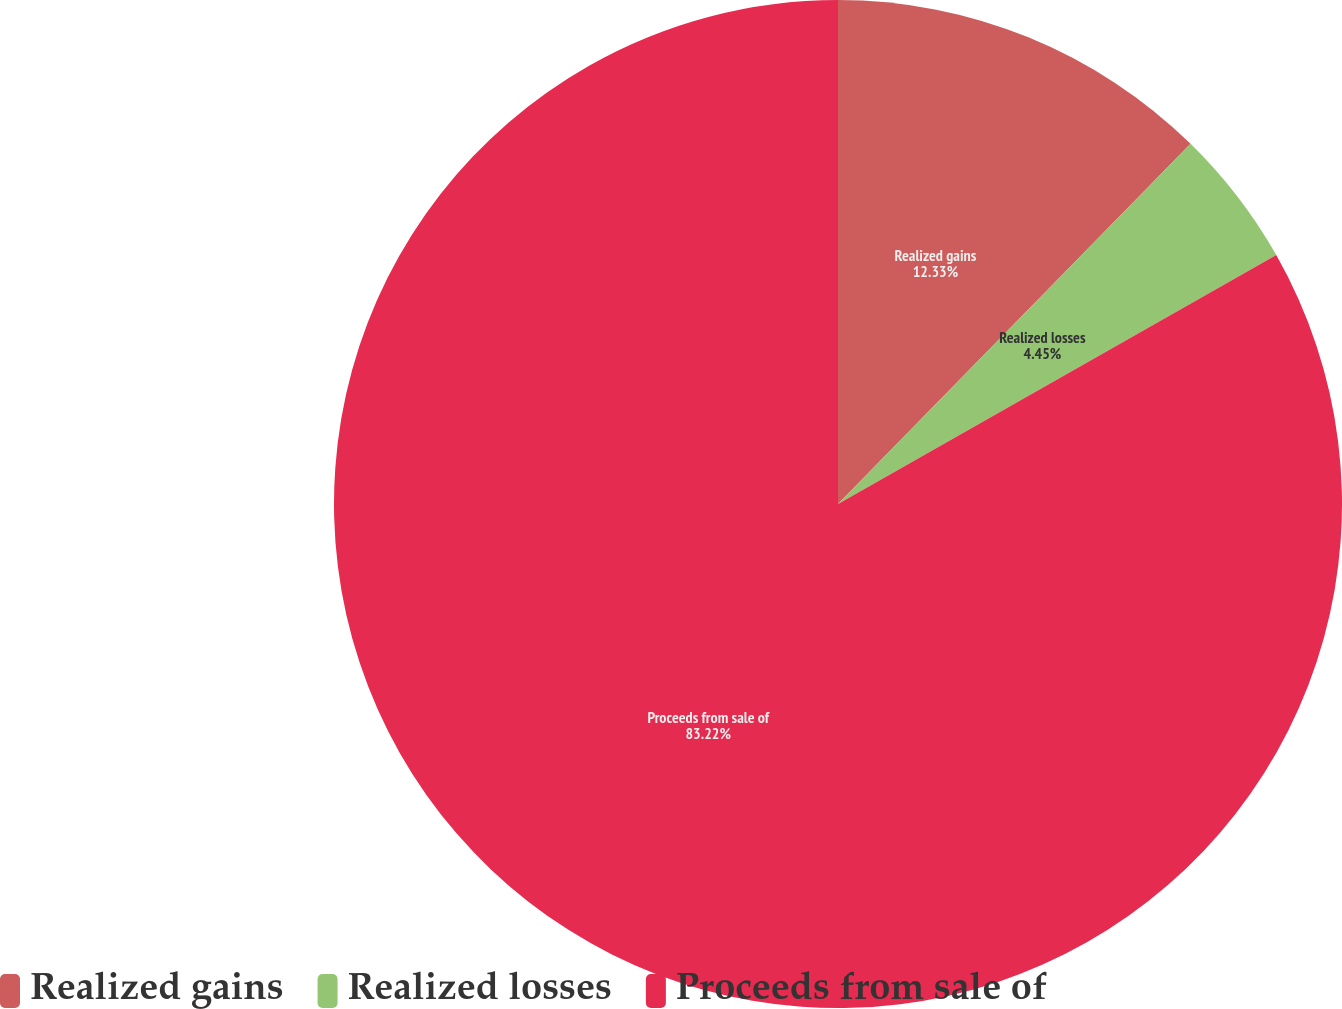Convert chart. <chart><loc_0><loc_0><loc_500><loc_500><pie_chart><fcel>Realized gains<fcel>Realized losses<fcel>Proceeds from sale of<nl><fcel>12.33%<fcel>4.45%<fcel>83.22%<nl></chart> 